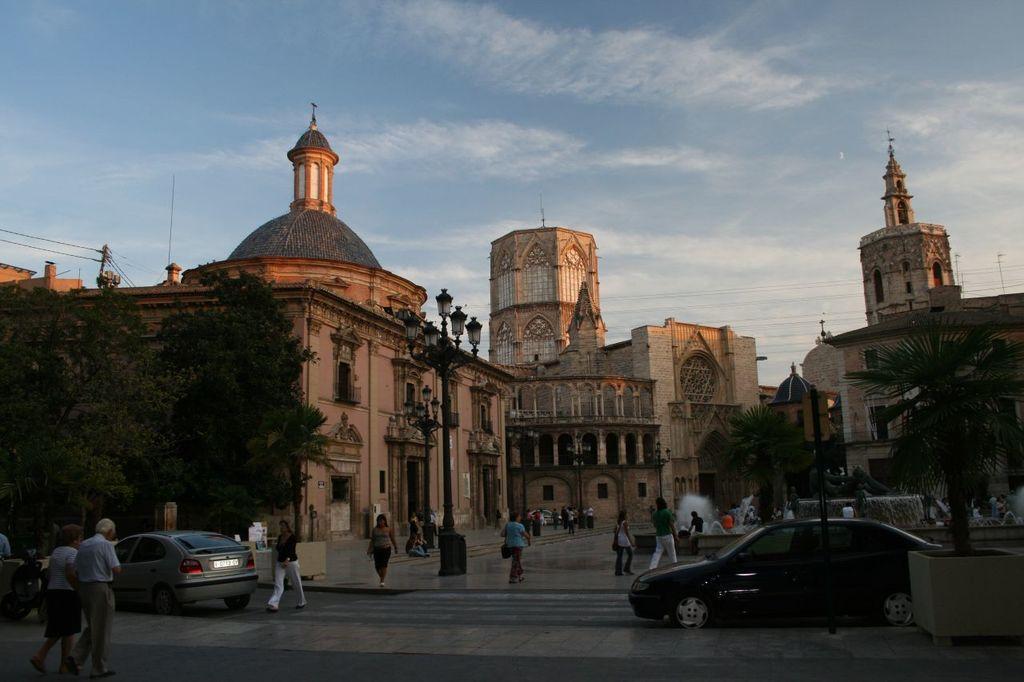Could you give a brief overview of what you see in this image? In this image I can see buildings. There are trees, vehicles, group of people, lights, cables, water fountains and in the background there is sky. 